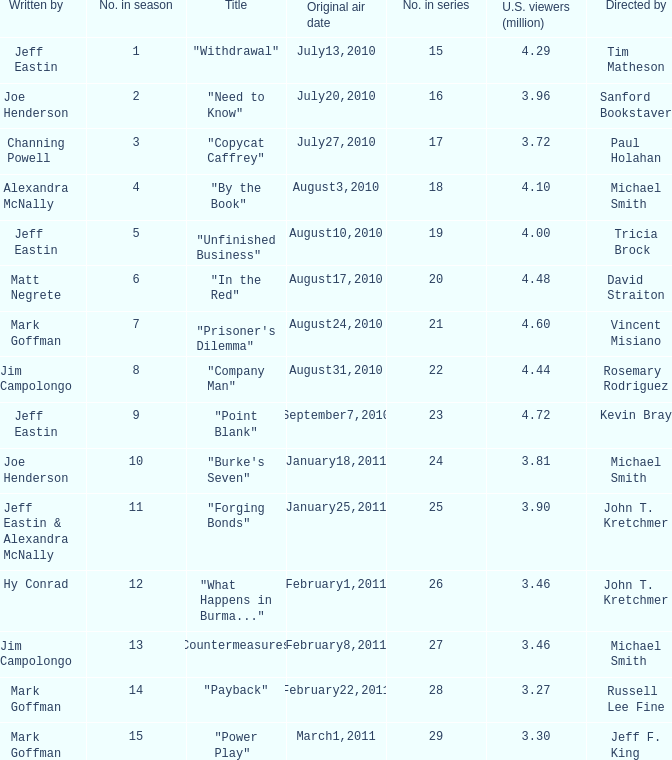Could you parse the entire table as a dict? {'header': ['Written by', 'No. in season', 'Title', 'Original air date', 'No. in series', 'U.S. viewers (million)', 'Directed by'], 'rows': [['Jeff Eastin', '1', '"Withdrawal"', 'July13,2010', '15', '4.29', 'Tim Matheson'], ['Joe Henderson', '2', '"Need to Know"', 'July20,2010', '16', '3.96', 'Sanford Bookstaver'], ['Channing Powell', '3', '"Copycat Caffrey"', 'July27,2010', '17', '3.72', 'Paul Holahan'], ['Alexandra McNally', '4', '"By the Book"', 'August3,2010', '18', '4.10', 'Michael Smith'], ['Jeff Eastin', '5', '"Unfinished Business"', 'August10,2010', '19', '4.00', 'Tricia Brock'], ['Matt Negrete', '6', '"In the Red"', 'August17,2010', '20', '4.48', 'David Straiton'], ['Mark Goffman', '7', '"Prisoner\'s Dilemma"', 'August24,2010', '21', '4.60', 'Vincent Misiano'], ['Jim Campolongo', '8', '"Company Man"', 'August31,2010', '22', '4.44', 'Rosemary Rodriguez'], ['Jeff Eastin', '9', '"Point Blank"', 'September7,2010', '23', '4.72', 'Kevin Bray'], ['Joe Henderson', '10', '"Burke\'s Seven"', 'January18,2011', '24', '3.81', 'Michael Smith'], ['Jeff Eastin & Alexandra McNally', '11', '"Forging Bonds"', 'January25,2011', '25', '3.90', 'John T. Kretchmer'], ['Hy Conrad', '12', '"What Happens in Burma..."', 'February1,2011', '26', '3.46', 'John T. Kretchmer'], ['Jim Campolongo', '13', '"Countermeasures"', 'February8,2011', '27', '3.46', 'Michael Smith'], ['Mark Goffman', '14', '"Payback"', 'February22,2011', '28', '3.27', 'Russell Lee Fine'], ['Mark Goffman', '15', '"Power Play"', 'March1,2011', '29', '3.30', 'Jeff F. King']]} How many millions of people in the US watched when Kevin Bray was director? 4.72. 